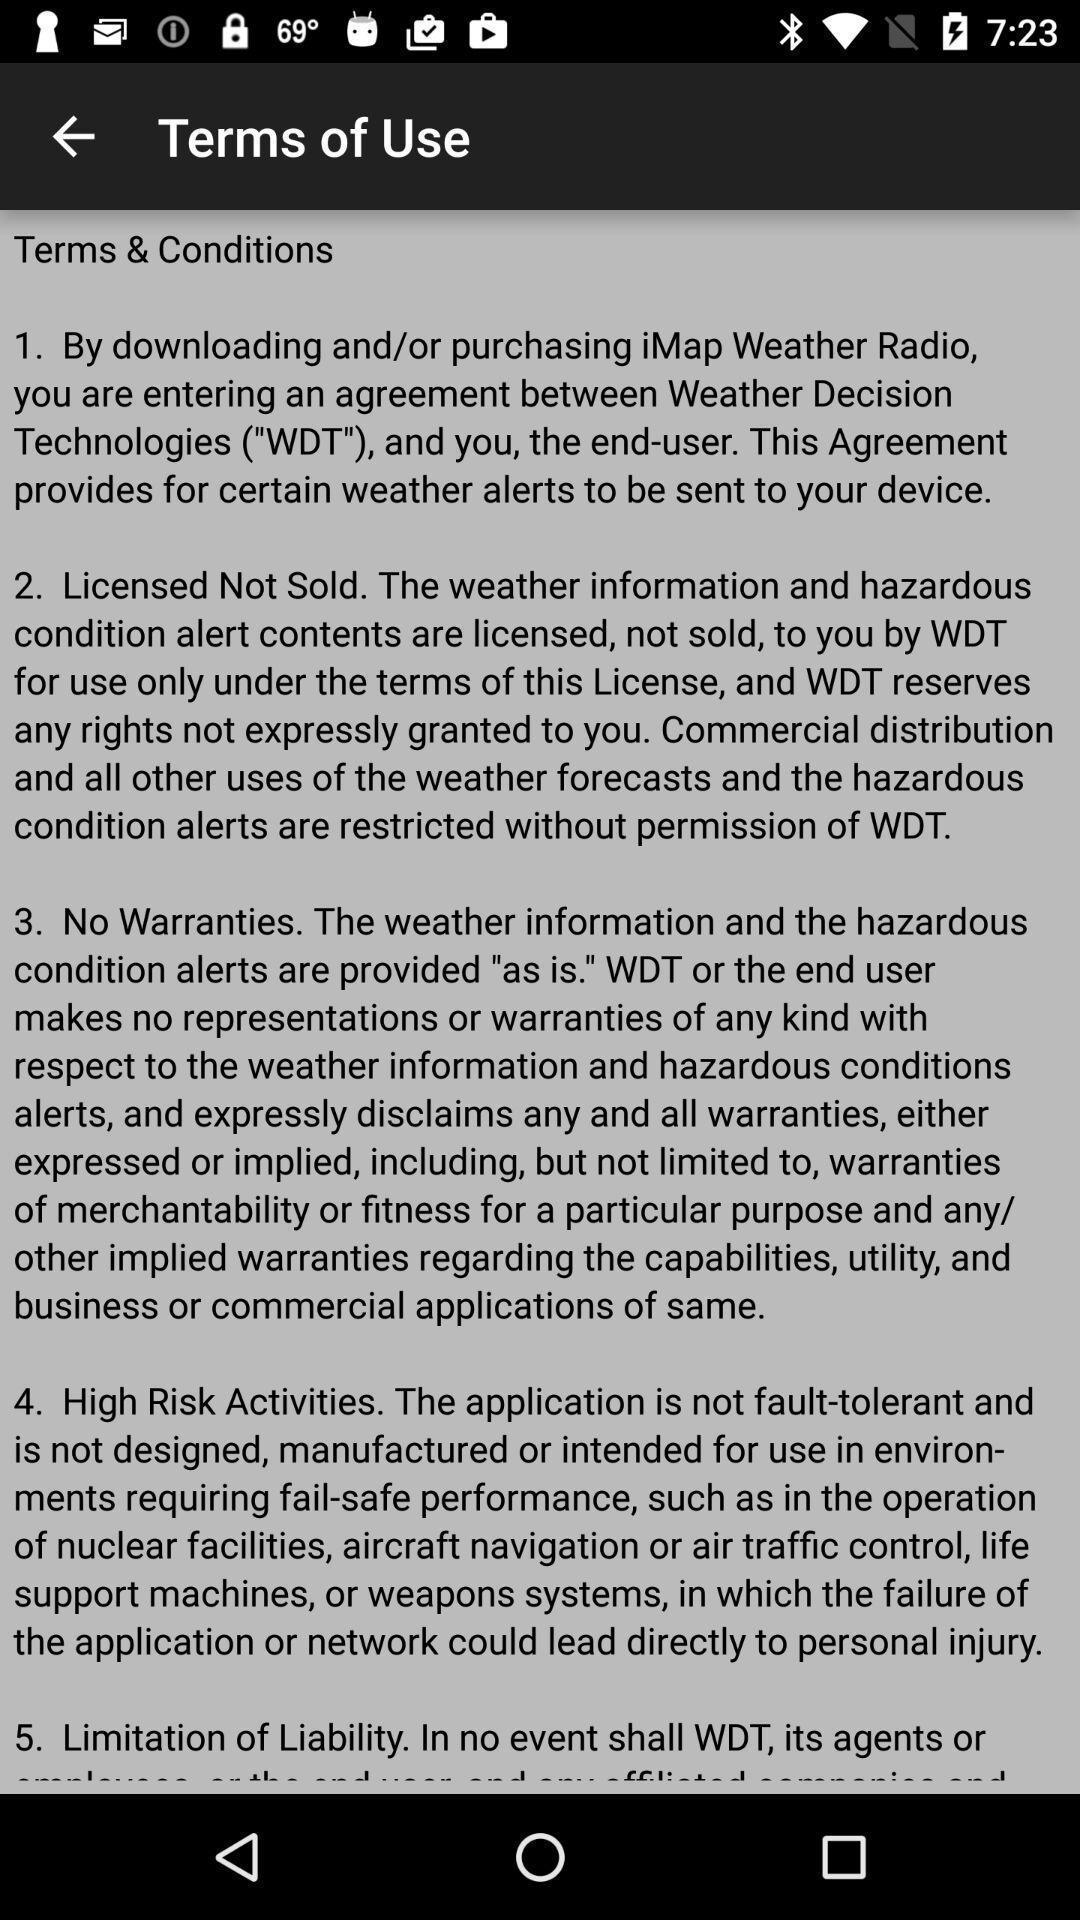Provide a detailed account of this screenshot. Page showing terms and conditions of a weather app. 